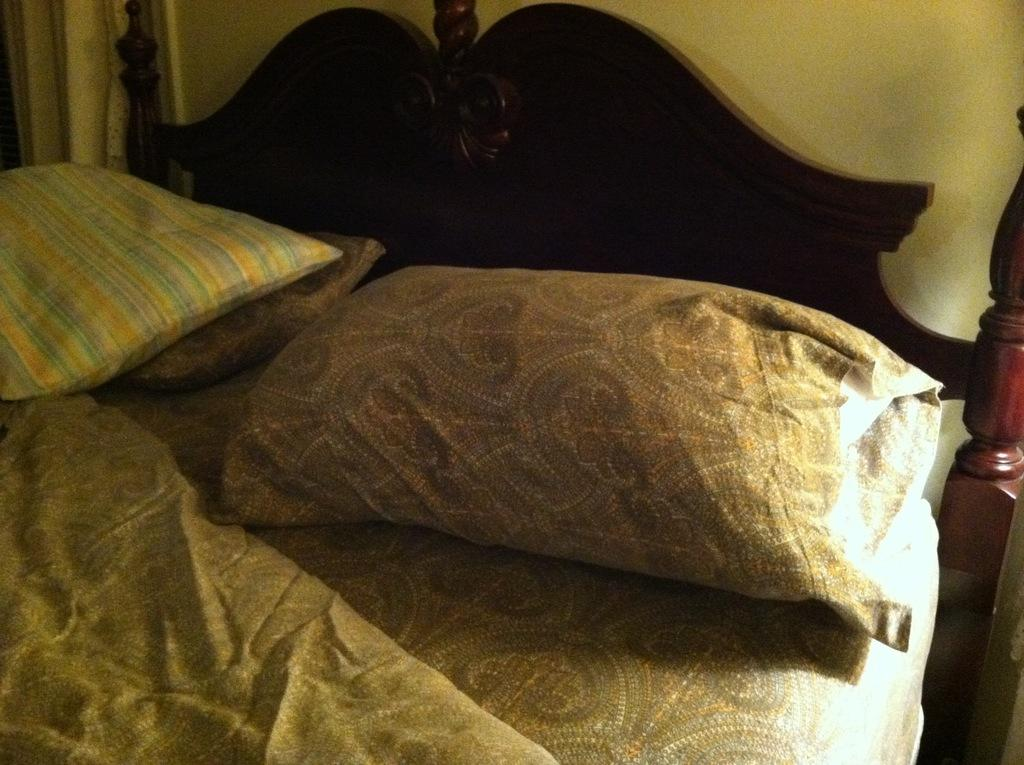What type of furniture is present in the image? There is a bed in the image. What is placed on the bed? There are pillows on the bed. What type of mine is depicted in the image? There is no mine present in the image; it features a bed with pillows. Where is the meeting taking place in the image? There is no meeting taking place in the image; it features a bed with pillows. 